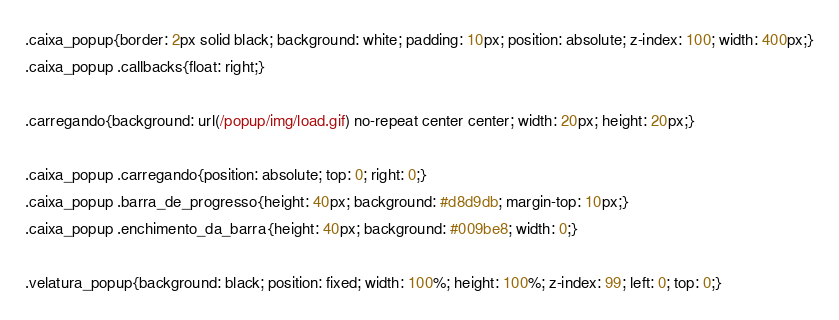<code> <loc_0><loc_0><loc_500><loc_500><_CSS_>.caixa_popup{border: 2px solid black; background: white; padding: 10px; position: absolute; z-index: 100; width: 400px;}
.caixa_popup .callbacks{float: right;}

.carregando{background: url(/popup/img/load.gif) no-repeat center center; width: 20px; height: 20px;}

.caixa_popup .carregando{position: absolute; top: 0; right: 0;}
.caixa_popup .barra_de_progresso{height: 40px; background: #d8d9db; margin-top: 10px;}
.caixa_popup .enchimento_da_barra{height: 40px; background: #009be8; width: 0;}

.velatura_popup{background: black; position: fixed; width: 100%; height: 100%; z-index: 99; left: 0; top: 0;}</code> 